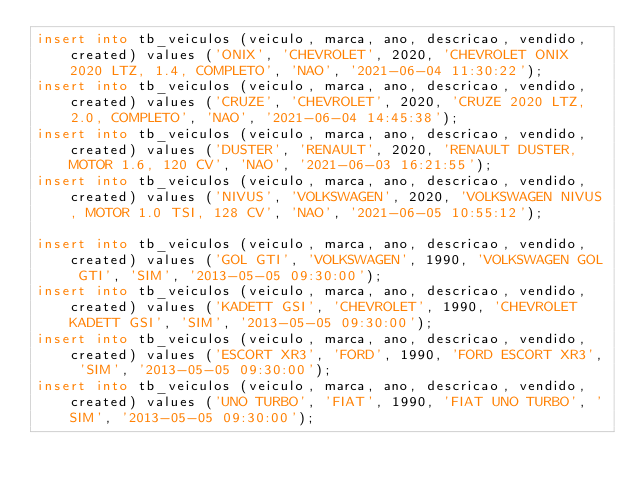Convert code to text. <code><loc_0><loc_0><loc_500><loc_500><_SQL_>insert into tb_veiculos (veiculo, marca, ano, descricao, vendido, created) values ('ONIX', 'CHEVROLET', 2020, 'CHEVROLET ONIX 2020 LTZ, 1.4, COMPLETO', 'NAO', '2021-06-04 11:30:22');
insert into tb_veiculos (veiculo, marca, ano, descricao, vendido, created) values ('CRUZE', 'CHEVROLET', 2020, 'CRUZE 2020 LTZ, 2.0, COMPLETO', 'NAO', '2021-06-04 14:45:38');
insert into tb_veiculos (veiculo, marca, ano, descricao, vendido, created) values ('DUSTER', 'RENAULT', 2020, 'RENAULT DUSTER, MOTOR 1.6, 120 CV', 'NAO', '2021-06-03 16:21:55');
insert into tb_veiculos (veiculo, marca, ano, descricao, vendido, created) values ('NIVUS', 'VOLKSWAGEN', 2020, 'VOLKSWAGEN NIVUS, MOTOR 1.0 TSI, 128 CV', 'NAO', '2021-06-05 10:55:12');

insert into tb_veiculos (veiculo, marca, ano, descricao, vendido, created) values ('GOL GTI', 'VOLKSWAGEN', 1990, 'VOLKSWAGEN GOL GTI', 'SIM', '2013-05-05 09:30:00');
insert into tb_veiculos (veiculo, marca, ano, descricao, vendido, created) values ('KADETT GSI', 'CHEVROLET', 1990, 'CHEVROLET KADETT GSI', 'SIM', '2013-05-05 09:30:00');
insert into tb_veiculos (veiculo, marca, ano, descricao, vendido, created) values ('ESCORT XR3', 'FORD', 1990, 'FORD ESCORT XR3', 'SIM', '2013-05-05 09:30:00');
insert into tb_veiculos (veiculo, marca, ano, descricao, vendido, created) values ('UNO TURBO', 'FIAT', 1990, 'FIAT UNO TURBO', 'SIM', '2013-05-05 09:30:00');</code> 